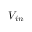Convert formula to latex. <formula><loc_0><loc_0><loc_500><loc_500>V _ { i n }</formula> 